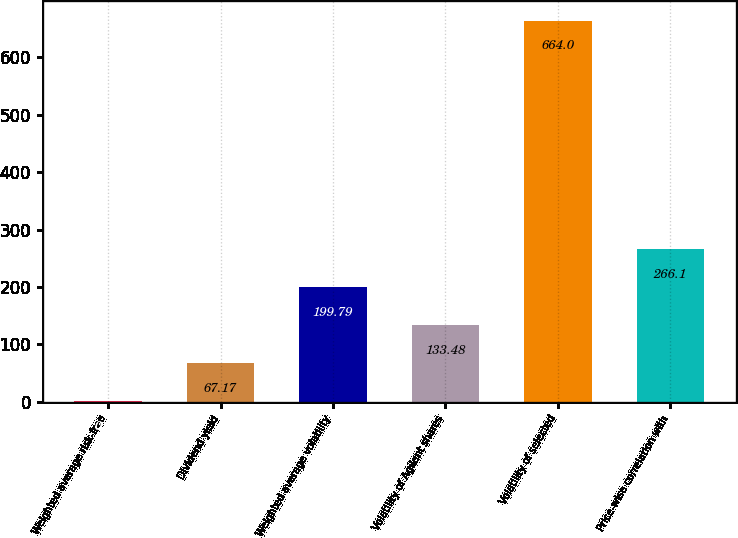Convert chart to OTSL. <chart><loc_0><loc_0><loc_500><loc_500><bar_chart><fcel>Weighted average risk-free<fcel>Dividend yield<fcel>Weighted average volatility<fcel>Volatility of Agilent shares<fcel>Volatility of selected<fcel>Price-wise correlation with<nl><fcel>0.86<fcel>67.17<fcel>199.79<fcel>133.48<fcel>664<fcel>266.1<nl></chart> 